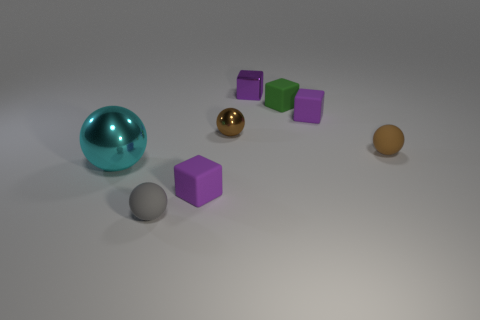Do the tiny gray thing and the tiny brown sphere that is on the right side of the green block have the same material?
Your answer should be very brief. Yes. What number of blue things are spheres or big metal balls?
Make the answer very short. 0. Are any green blocks visible?
Ensure brevity in your answer.  Yes. There is a tiny sphere left of the matte cube that is on the left side of the metallic block; is there a big cyan metallic sphere that is right of it?
Your response must be concise. No. Is there any other thing that is the same size as the cyan metal thing?
Your response must be concise. No. Is the shape of the big metallic object the same as the purple thing in front of the large cyan shiny sphere?
Your response must be concise. No. The thing that is left of the small thing that is left of the small purple block on the left side of the small metallic sphere is what color?
Give a very brief answer. Cyan. What number of things are either small purple blocks that are behind the green matte cube or balls that are on the right side of the gray matte sphere?
Make the answer very short. 3. How many other objects are there of the same color as the big ball?
Give a very brief answer. 0. Is the shape of the purple rubber object that is left of the small metal cube the same as  the small purple metallic object?
Offer a very short reply. Yes. 